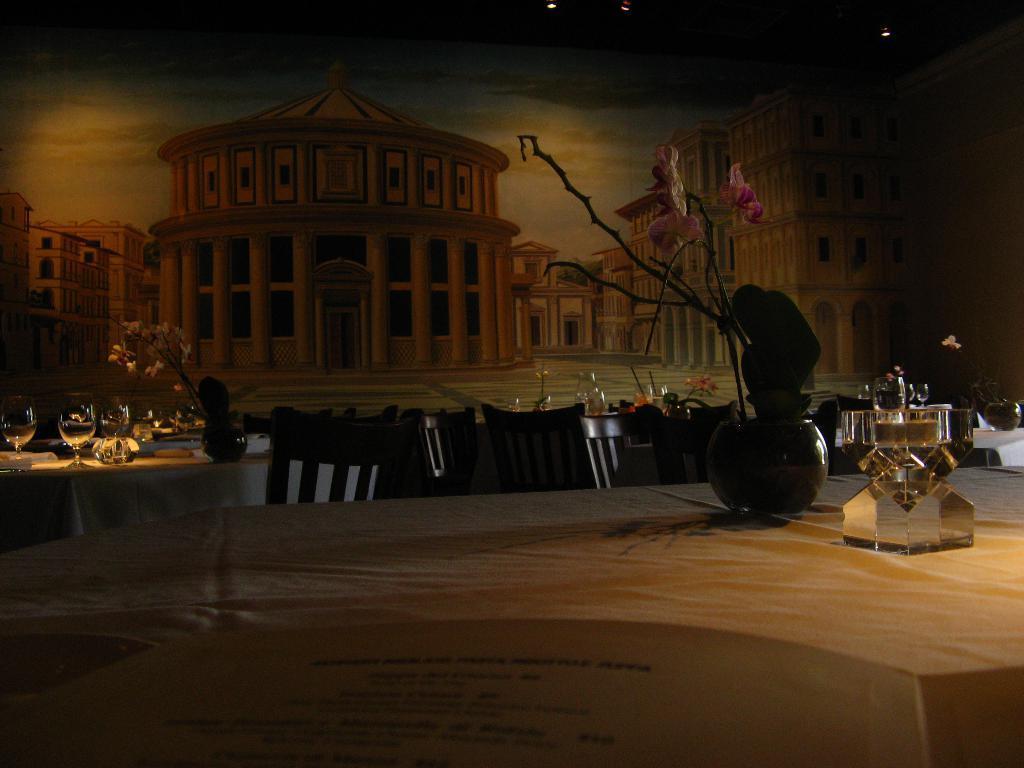Describe this image in one or two sentences. In this image we can see there are tables, on the table there is a cloth, glasses, potted plants and stand made of glass. At the back there is a poster, in that there are buildings. At the top there is a ceiling with lights. 